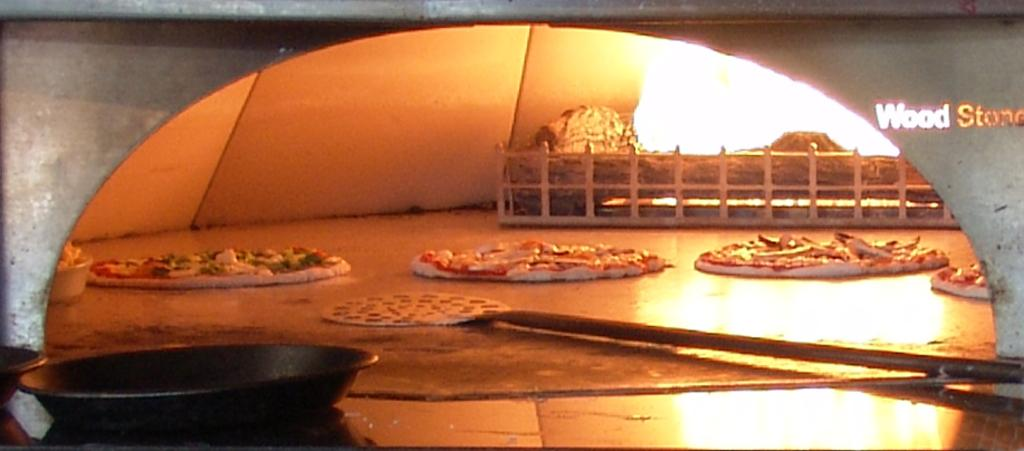Provide a one-sentence caption for the provided image. Pizzd is baking in an oven with has "Wood Stone" in gold letters to one side. 